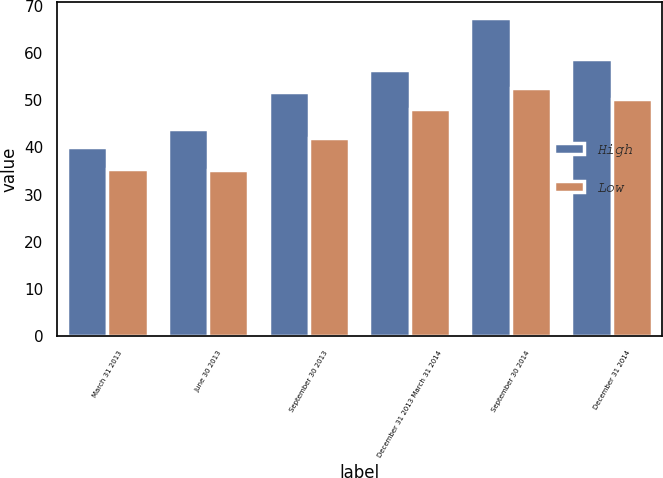<chart> <loc_0><loc_0><loc_500><loc_500><stacked_bar_chart><ecel><fcel>March 31 2013<fcel>June 30 2013<fcel>September 30 2013<fcel>December 31 2013 March 31 2014<fcel>September 30 2014<fcel>December 31 2014<nl><fcel>High<fcel>40.05<fcel>43.83<fcel>51.63<fcel>56.45<fcel>67.38<fcel>58.75<nl><fcel>Low<fcel>35.51<fcel>35.22<fcel>42.07<fcel>48.13<fcel>52.61<fcel>50.24<nl></chart> 